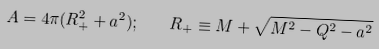<formula> <loc_0><loc_0><loc_500><loc_500>A = 4 \pi ( R _ { + } ^ { 2 } + a ^ { 2 } ) ; \quad R _ { + } \equiv M + \sqrt { M ^ { 2 } - Q ^ { 2 } - a ^ { 2 } }</formula> 